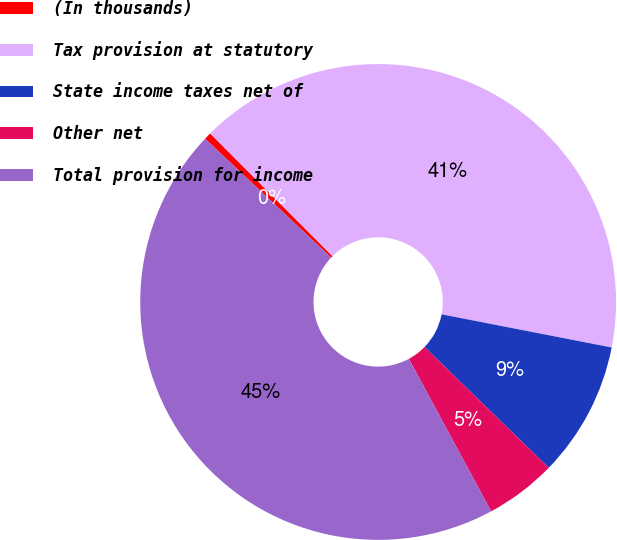<chart> <loc_0><loc_0><loc_500><loc_500><pie_chart><fcel>(In thousands)<fcel>Tax provision at statutory<fcel>State income taxes net of<fcel>Other net<fcel>Total provision for income<nl><fcel>0.49%<fcel>40.54%<fcel>9.21%<fcel>4.85%<fcel>44.91%<nl></chart> 